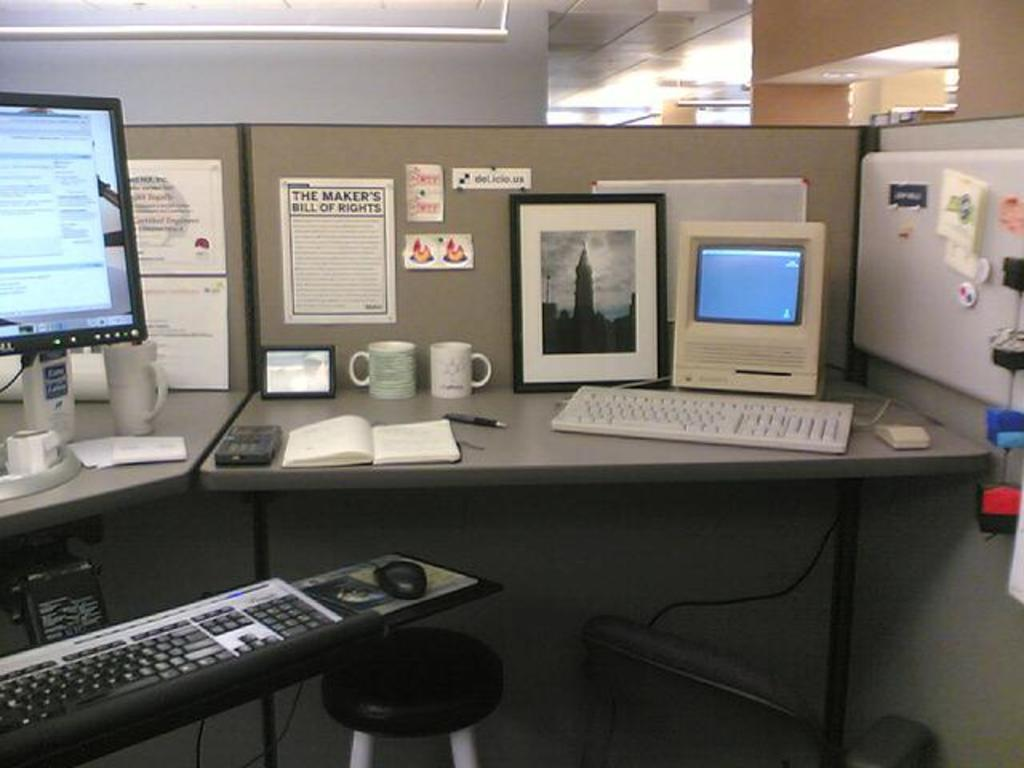<image>
Create a compact narrative representing the image presented. A neat cubicle with "the makers bill of rights" hanging on the wall,. 